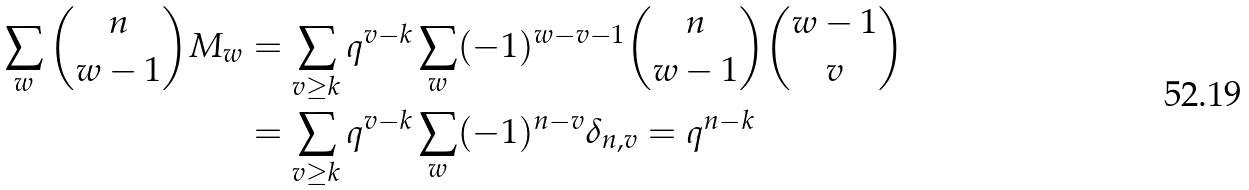<formula> <loc_0><loc_0><loc_500><loc_500>\sum _ { w } \binom { n } { w - 1 } M _ { w } & = \sum _ { v \geq k } q ^ { v - k } \sum _ { w } ( - 1 ) ^ { w - v - 1 } \binom { n } { w - 1 } \binom { w - 1 } { v } \\ & = \sum _ { v \geq k } q ^ { v - k } \sum _ { w } ( - 1 ) ^ { n - v } \delta _ { n , v } = q ^ { n - k }</formula> 